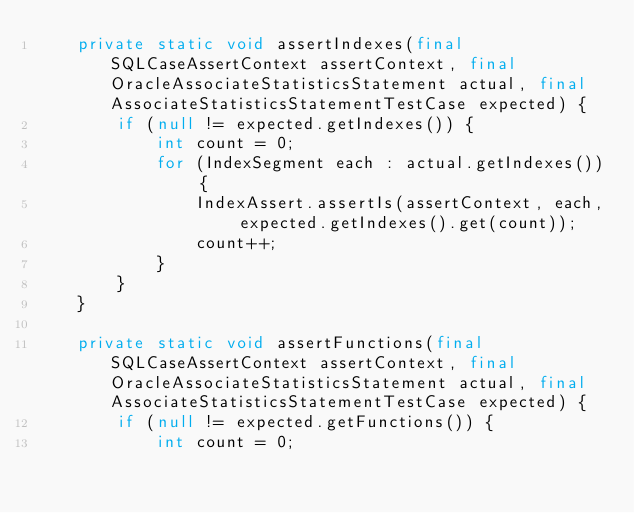Convert code to text. <code><loc_0><loc_0><loc_500><loc_500><_Java_>    private static void assertIndexes(final SQLCaseAssertContext assertContext, final OracleAssociateStatisticsStatement actual, final AssociateStatisticsStatementTestCase expected) {
        if (null != expected.getIndexes()) {
            int count = 0;
            for (IndexSegment each : actual.getIndexes()) {
                IndexAssert.assertIs(assertContext, each, expected.getIndexes().get(count));
                count++;
            }
        }
    }

    private static void assertFunctions(final SQLCaseAssertContext assertContext, final OracleAssociateStatisticsStatement actual, final AssociateStatisticsStatementTestCase expected) {
        if (null != expected.getFunctions()) {
            int count = 0;</code> 